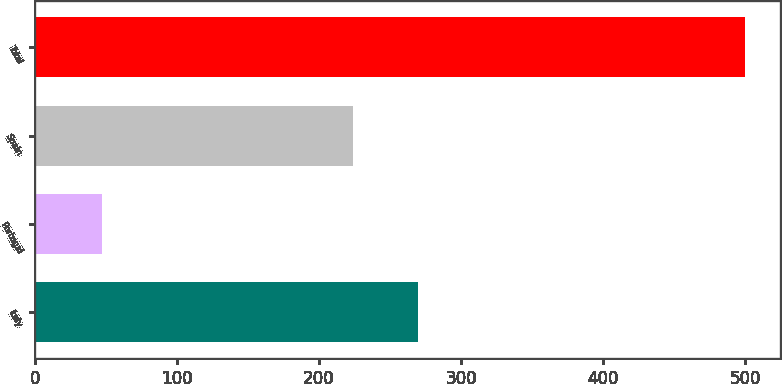<chart> <loc_0><loc_0><loc_500><loc_500><bar_chart><fcel>Italy<fcel>Portugal<fcel>Spain<fcel>Total<nl><fcel>269.37<fcel>47.1<fcel>224.1<fcel>499.8<nl></chart> 